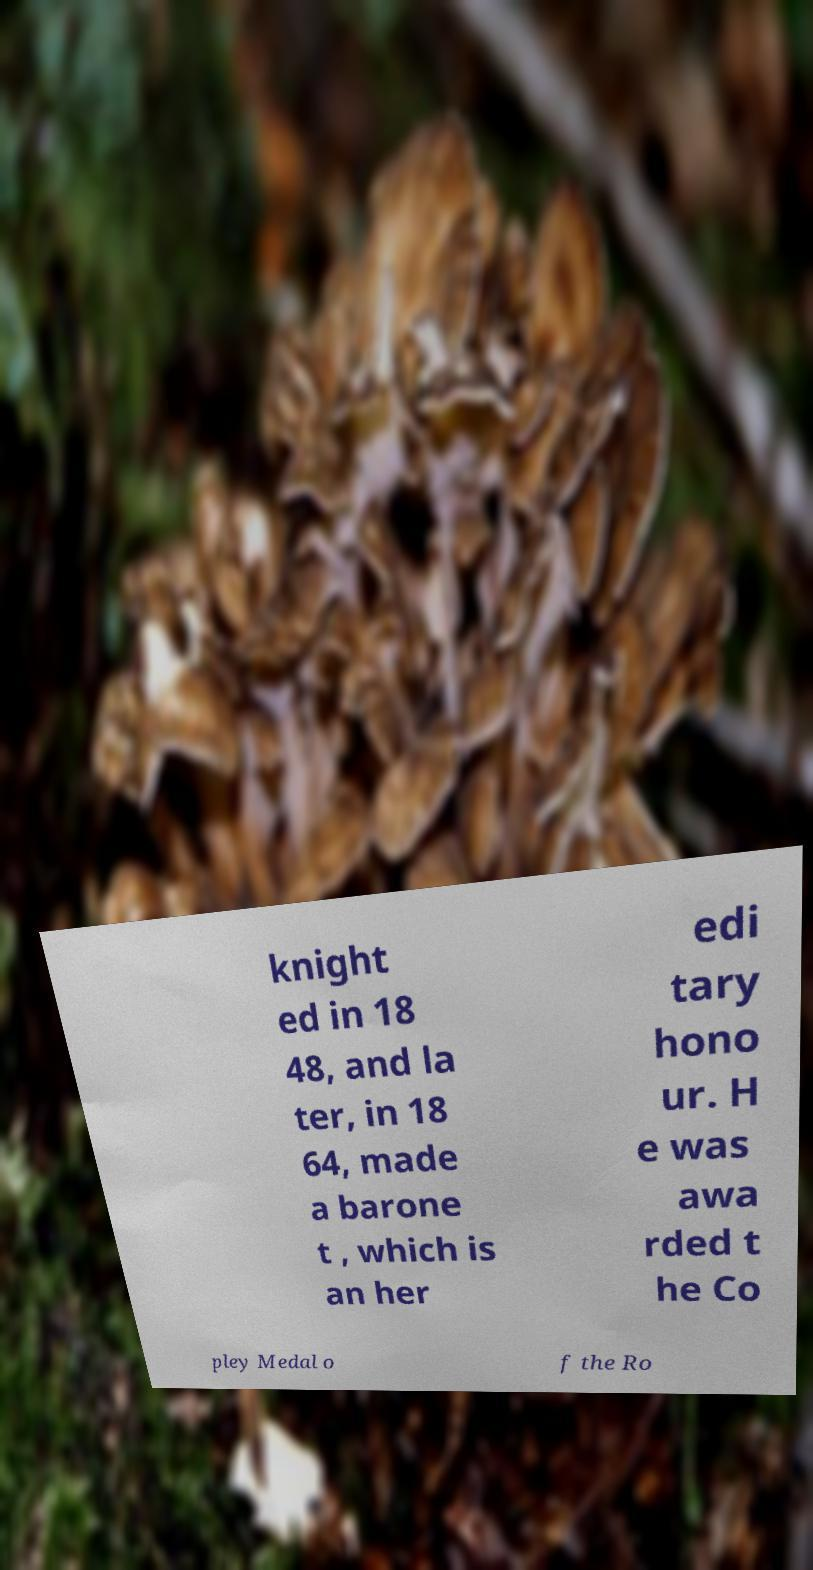For documentation purposes, I need the text within this image transcribed. Could you provide that? knight ed in 18 48, and la ter, in 18 64, made a barone t , which is an her edi tary hono ur. H e was awa rded t he Co pley Medal o f the Ro 